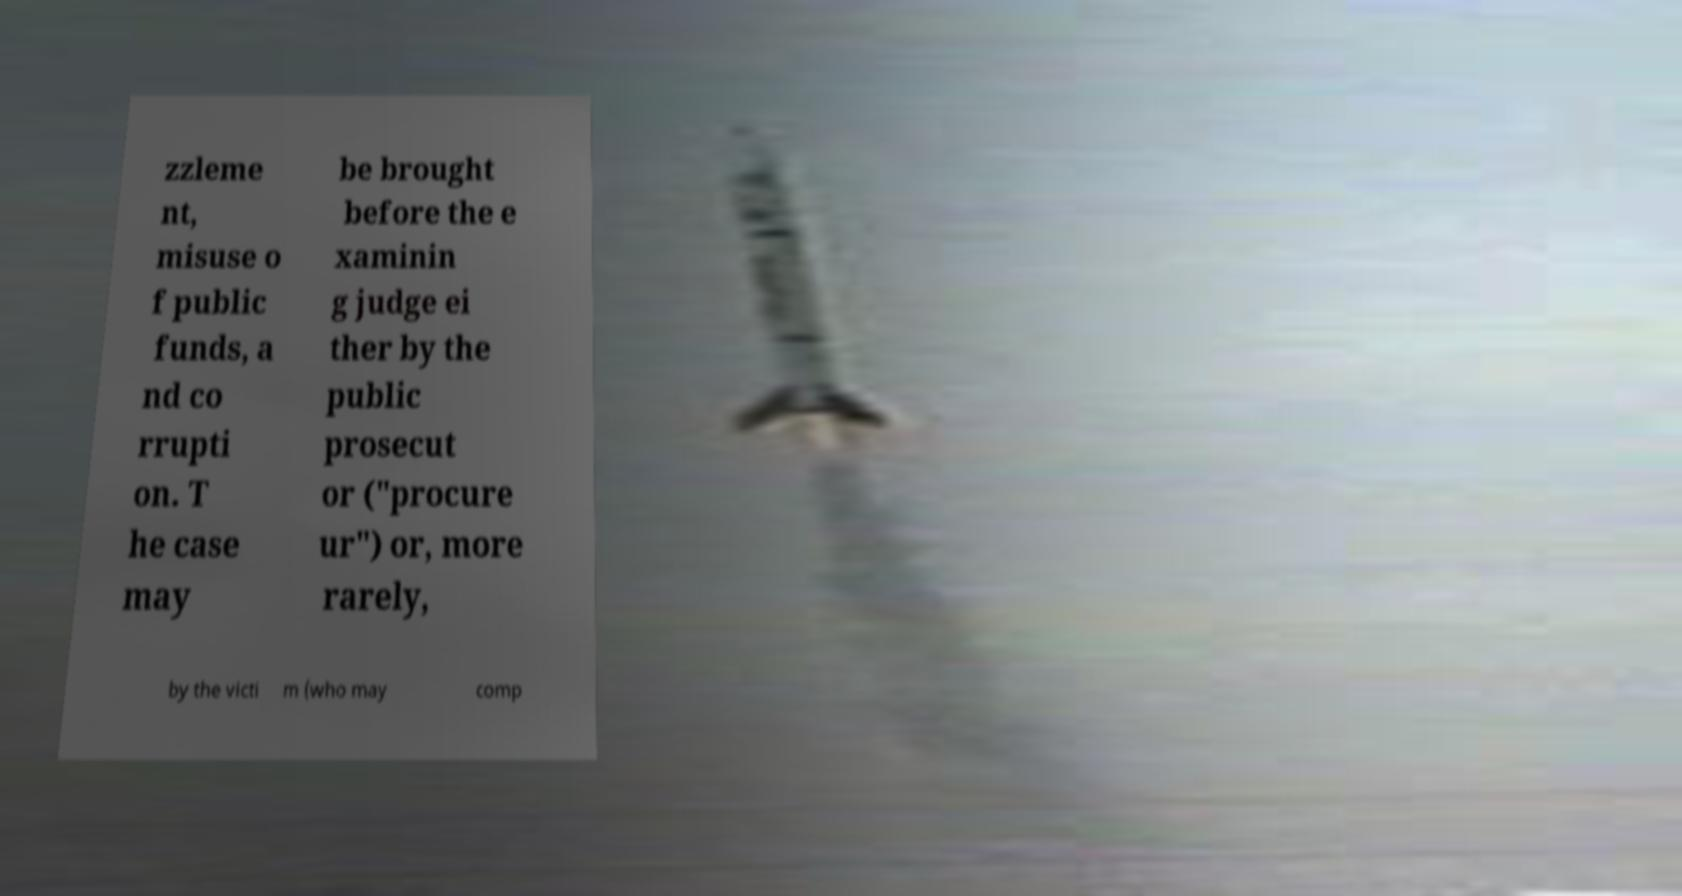What messages or text are displayed in this image? I need them in a readable, typed format. zzleme nt, misuse o f public funds, a nd co rrupti on. T he case may be brought before the e xaminin g judge ei ther by the public prosecut or ("procure ur") or, more rarely, by the victi m (who may comp 